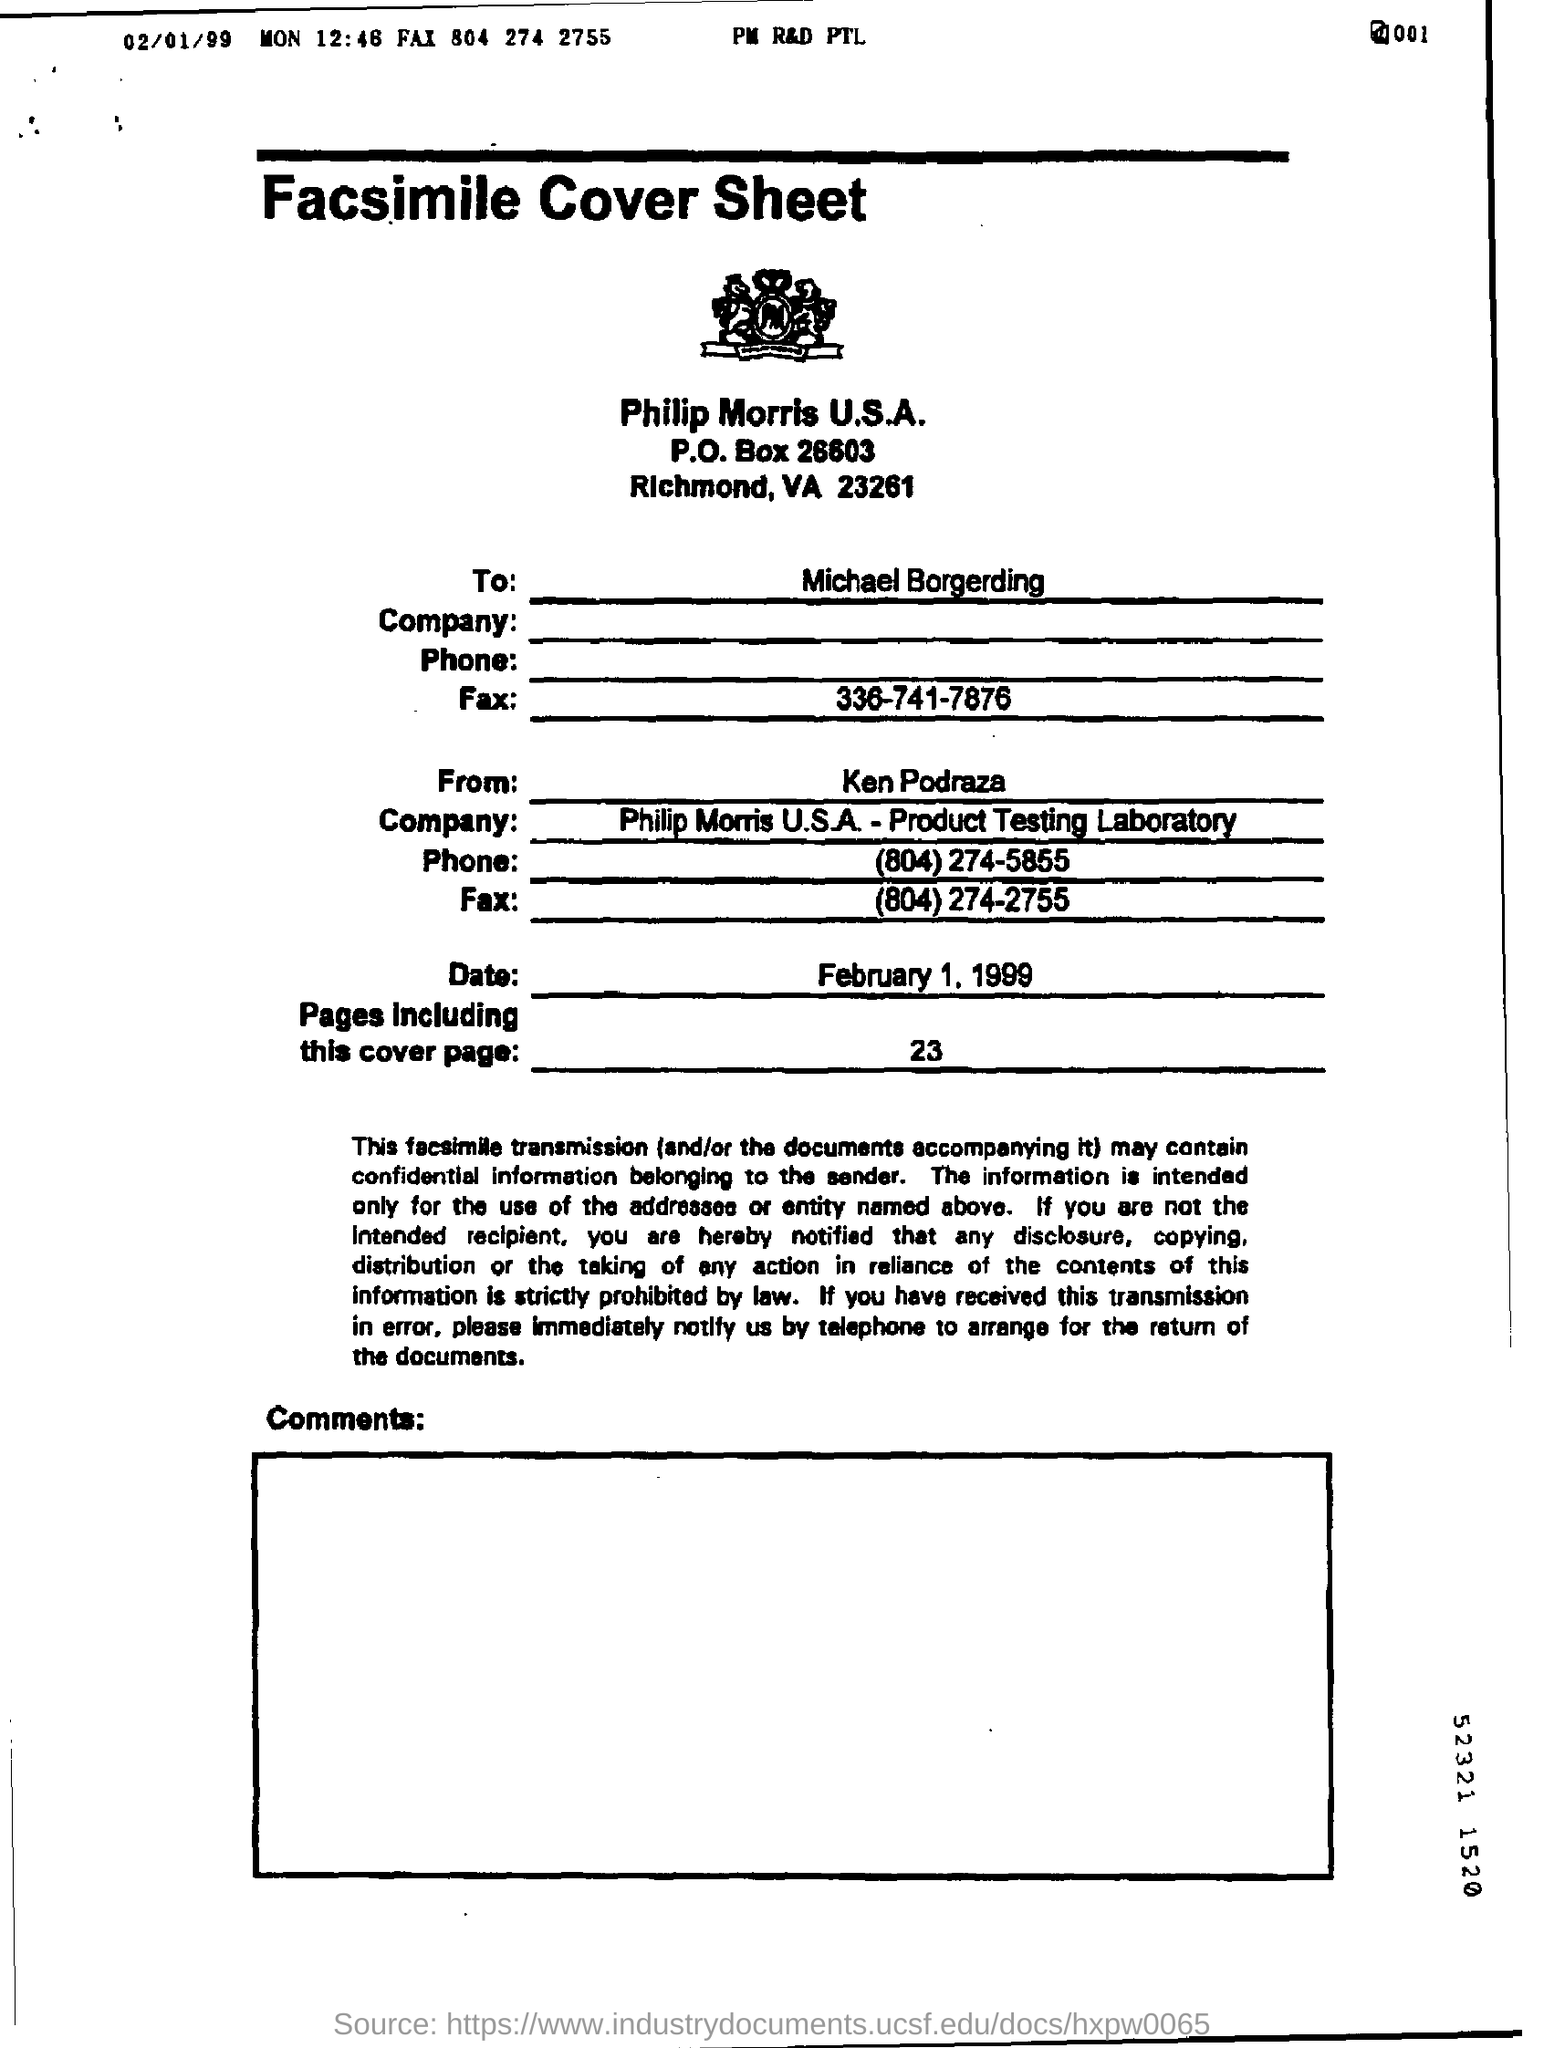Give some essential details in this illustration. There are 23 pages in total, including this cover page. The fax number that belongs to Michael Borgerding is 336-741-7876. 